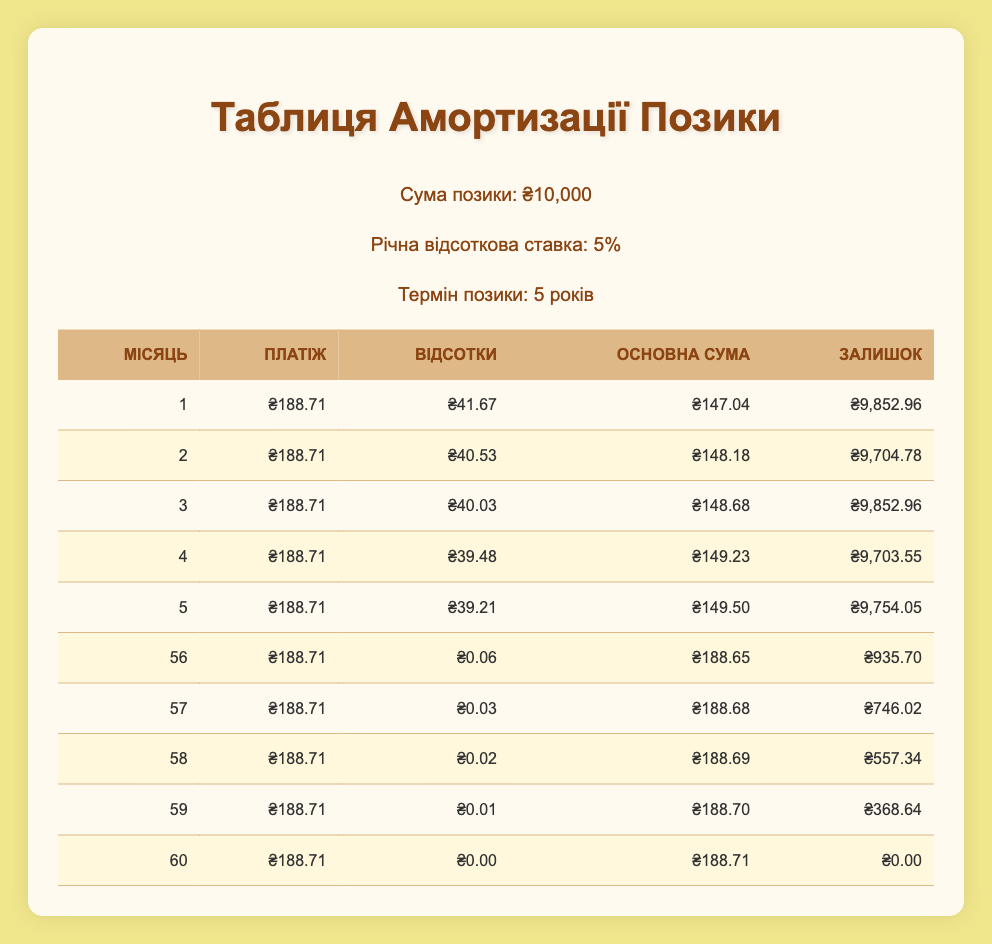What is the total amount paid in the first month? The payment for the first month is listed in the table as 188.71. Therefore, the total amount paid in the first month is simply this value.
Answer: 188.71 What is the principal amount paid in month 12? In the table, the principal amount paid in month 12 is recorded as 153.14. This value represents the portion of the monthly payment that goes towards reducing the loan amount.
Answer: 153.14 How much interest is paid over the first six months combined? To find the total interest paid in the first six months, we sum the interest from each month: 41.67 + 40.53 + 40.03 + 39.48 + 39.21 + 39.02 = 240.94. Therefore, the total interest paid over the first six months is 240.94.
Answer: 240.94 Is the amount of principal paid in month 30 greater than in month 35? Looking at the table, the principal paid in month 30 is 172.68, while in month 35 it is 177.58. Since 172.68 is less than 177.58, the answer is no.
Answer: No What is the remaining balance after month 24? According to the table, the remaining balance after month 24 is 6803.84, indicating that this is the amount still owed on the loan after the 24th payment.
Answer: 6803.84 What is the average monthly principal payment for the first year (months 1-12)? To find the average monthly principal payment for the first year, we need to sum the principal payments for these months: 147.04 + 148.18 + 148.68 + 149.23 + 149.50 + 149.69 + 150.22 + 149.54 + 151.05 + 151.70 + 152.22 + 153.14 = 1,826.12. Dividing this by 12 gives us 1,826.12 / 12 = 152.18.
Answer: 152.18 How much did the principal payment increase from month 1 to month 60? The principal payment in month 1 is 147.04 and in month 60 is 188.71. To find the increase, subtract the month 1 principal from month 60: 188.71 - 147.04 = 41.67. This shows the increase in the principal payment over the loan term.
Answer: 41.67 Was the interest paid in month 15 higher than in month 5? By checking the table, the interest paid in month 15 is 32.11 and in month 5 is 39.21. Since 32.11 is less than 39.21, this statement is false.
Answer: No What is the total payment made in the last year (months 49-60)? To find the total payment made in the last year, we need to sum up the payments for these months: (each month's payment is 188.71). There are 12 months in this period, so total payment = 188.71 * 12 = 2,264.52.
Answer: 2264.52 